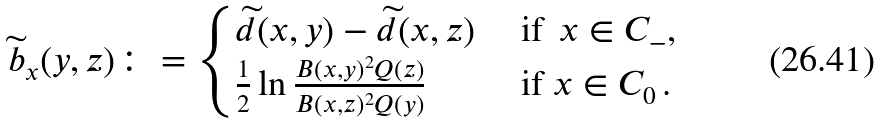<formula> <loc_0><loc_0><loc_500><loc_500>\widetilde { b } _ { x } ( y , z ) \colon = \begin{cases} \widetilde { d } ( x , y ) - \widetilde { d } ( x , z ) & \text { if } \, x \in C _ { - } , \\ \frac { 1 } { 2 } \ln \frac { B ( x , y ) ^ { 2 } Q ( z ) } { B ( x , z ) ^ { 2 } Q ( y ) } & \text { if } x \in C _ { 0 } \, . \end{cases}</formula> 